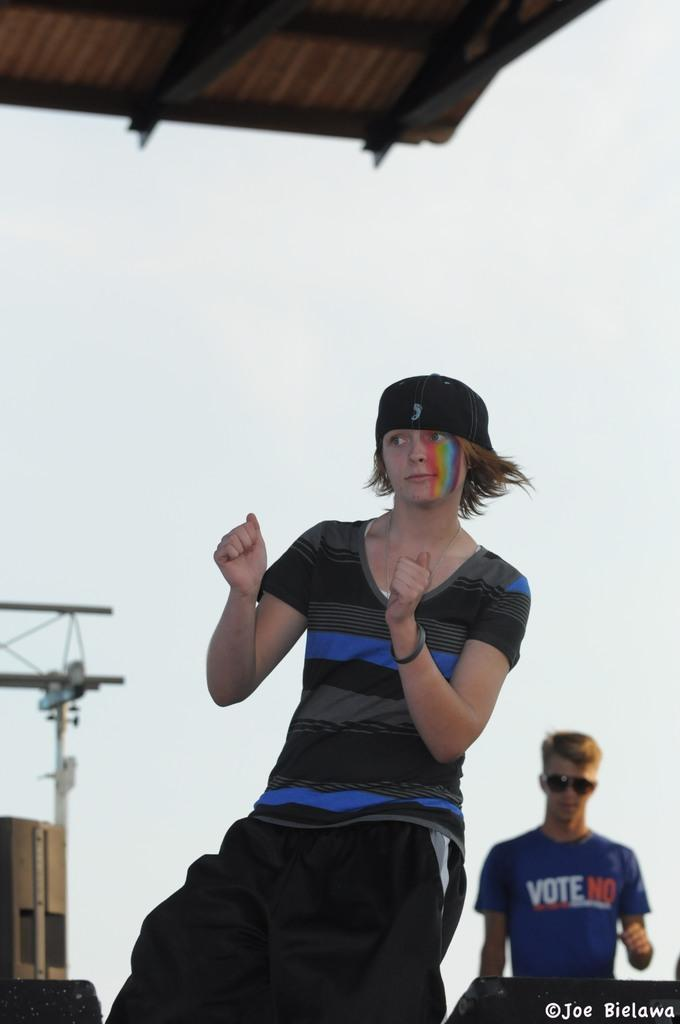<image>
Share a concise interpretation of the image provided. A DJ with a vote no shirt on standing on stage with a dancer. 